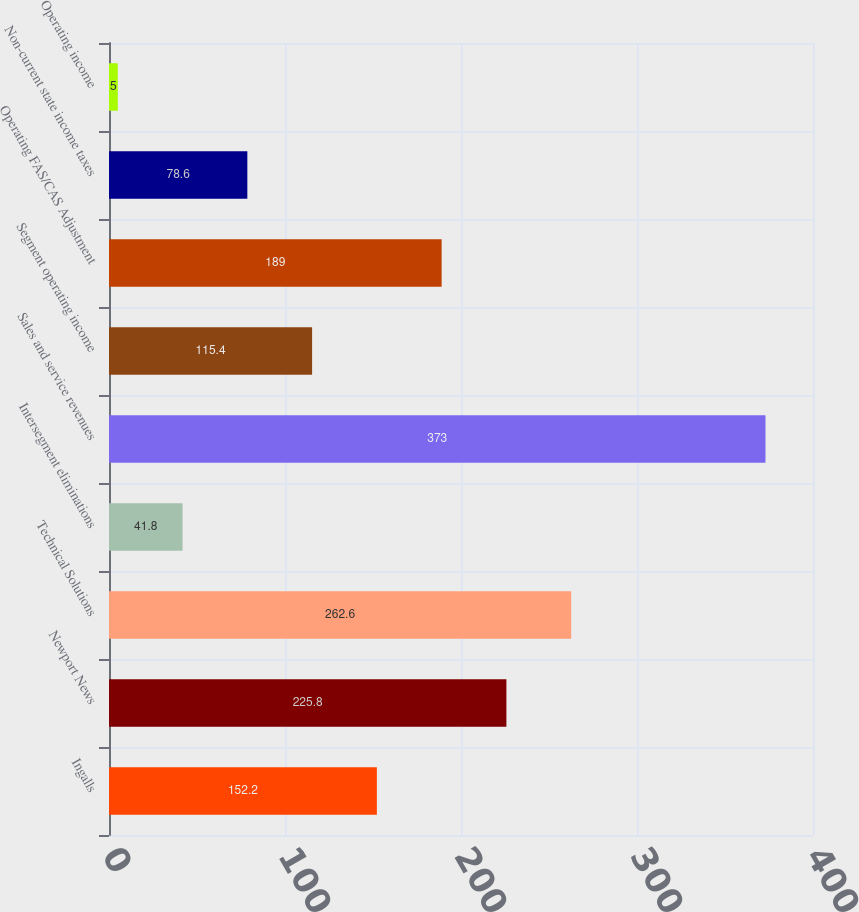Convert chart. <chart><loc_0><loc_0><loc_500><loc_500><bar_chart><fcel>Ingalls<fcel>Newport News<fcel>Technical Solutions<fcel>Intersegment eliminations<fcel>Sales and service revenues<fcel>Segment operating income<fcel>Operating FAS/CAS Adjustment<fcel>Non-current state income taxes<fcel>Operating income<nl><fcel>152.2<fcel>225.8<fcel>262.6<fcel>41.8<fcel>373<fcel>115.4<fcel>189<fcel>78.6<fcel>5<nl></chart> 